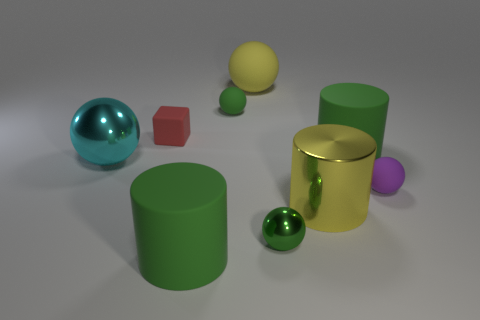Is there anything else that is the same size as the purple rubber object?
Your answer should be very brief. Yes. Is the number of tiny matte spheres in front of the tiny purple matte ball less than the number of small green balls?
Ensure brevity in your answer.  Yes. Does the tiny shiny thing have the same shape as the tiny purple matte object?
Offer a very short reply. Yes. There is a tiny shiny thing that is the same shape as the yellow rubber object; what is its color?
Your answer should be compact. Green. How many matte cylinders are the same color as the small shiny object?
Keep it short and to the point. 2. What number of objects are green matte cylinders on the right side of the small green shiny ball or tiny brown spheres?
Ensure brevity in your answer.  1. What size is the green sphere behind the big cyan object?
Your answer should be very brief. Small. Are there fewer big green cylinders than gray rubber blocks?
Your answer should be compact. No. Are the green cylinder in front of the cyan ball and the green cylinder that is on the right side of the big yellow ball made of the same material?
Your answer should be very brief. Yes. What shape is the tiny matte object that is on the left side of the big green cylinder in front of the rubber cylinder that is behind the green shiny thing?
Provide a short and direct response. Cube. 